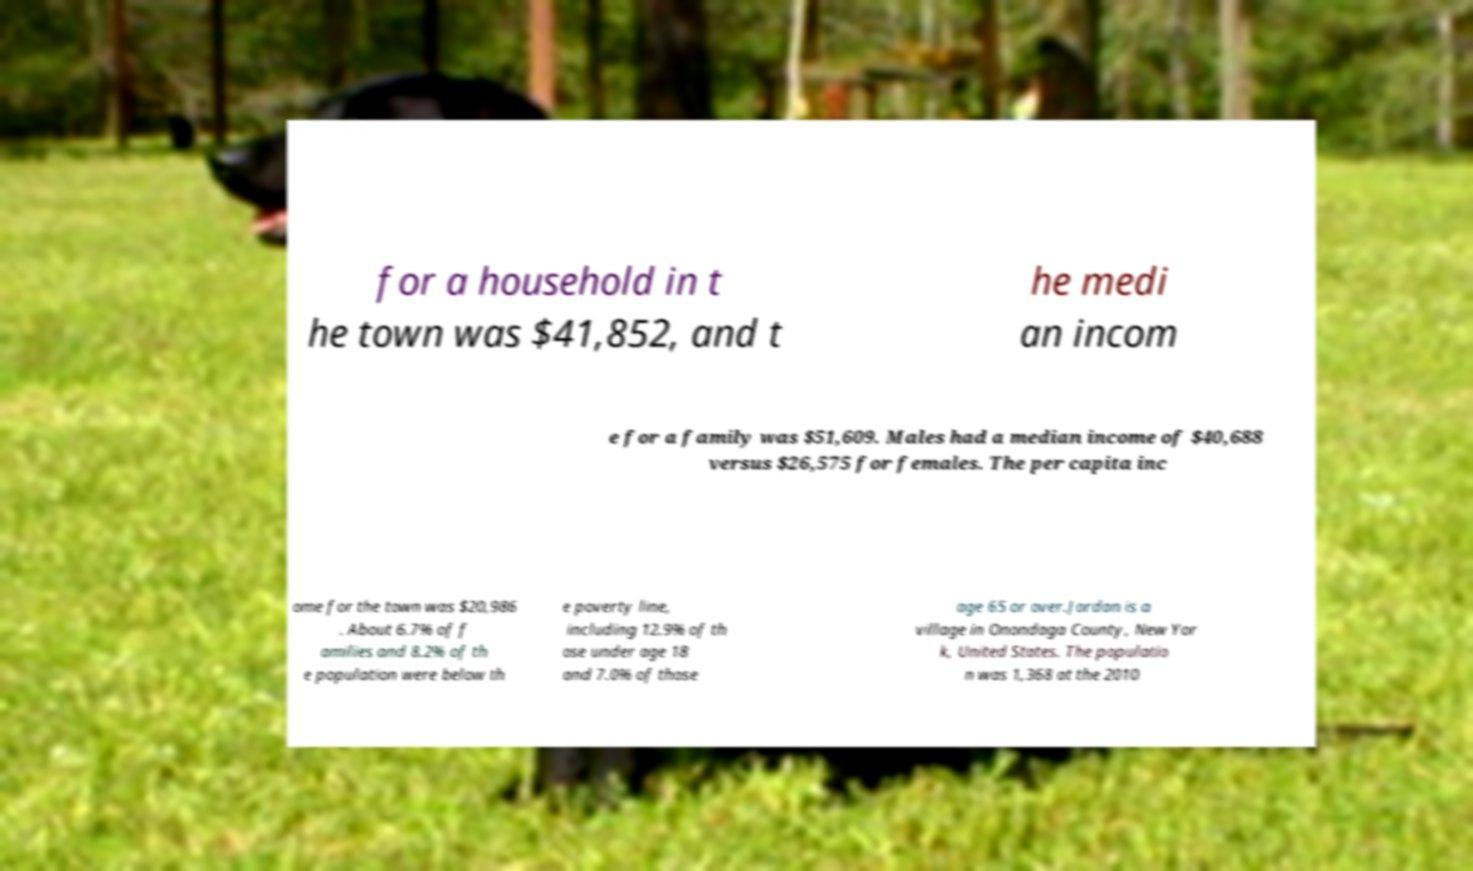I need the written content from this picture converted into text. Can you do that? for a household in t he town was $41,852, and t he medi an incom e for a family was $51,609. Males had a median income of $40,688 versus $26,575 for females. The per capita inc ome for the town was $20,986 . About 6.7% of f amilies and 8.2% of th e population were below th e poverty line, including 12.9% of th ose under age 18 and 7.0% of those age 65 or over.Jordan is a village in Onondaga County, New Yor k, United States. The populatio n was 1,368 at the 2010 